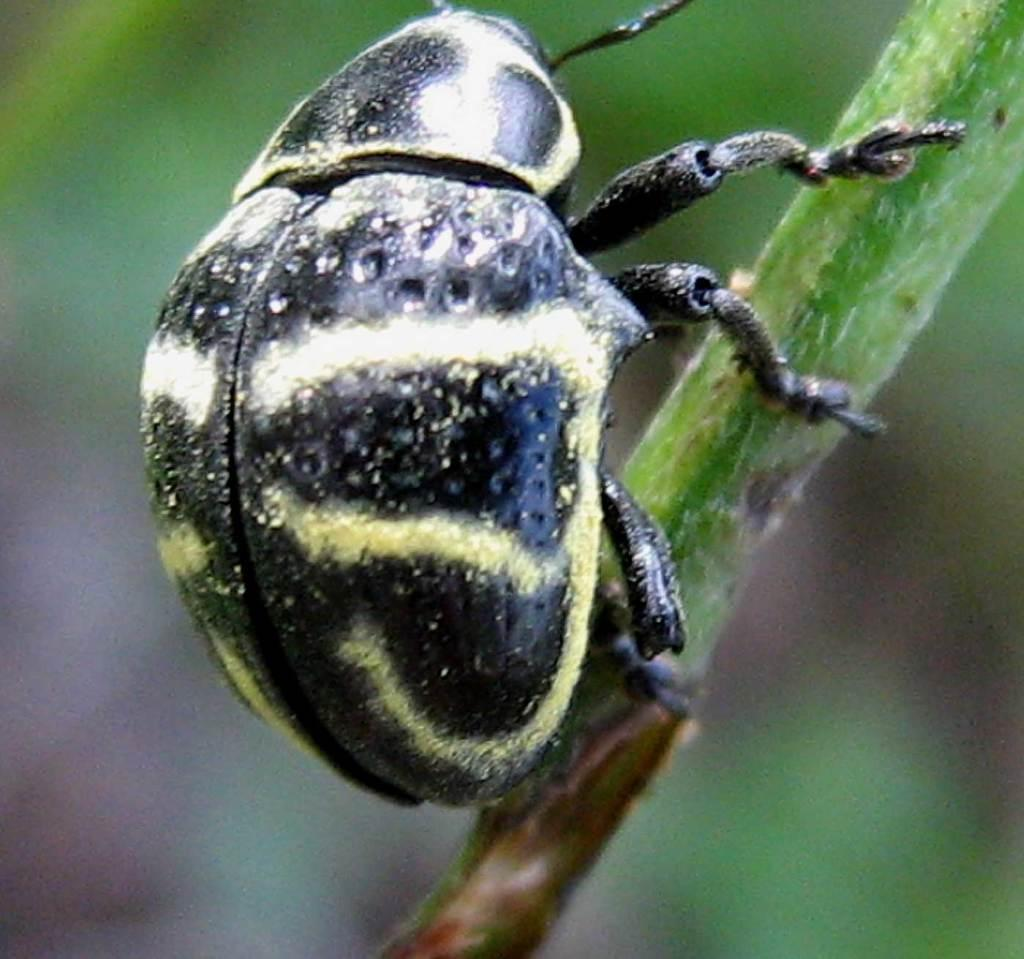What type of creature can be seen in the image? There is an insect in the image. Reasoning: Let's think step by identifying the main subject in the image, which is the insect. We formulate a question that focuses on the type of creature present in the image, ensuring that the answer can be definitively determined from the provided fact. Absurd Question/Answer: What plant is the insect attempting to fall from in the image? There is no plant present in the image, and the insect is not attempting to fall from anything. What plant is the insect attempting to fall from in the image? There is no plant present in the image, and the insect is not attempting to fall from anything. 